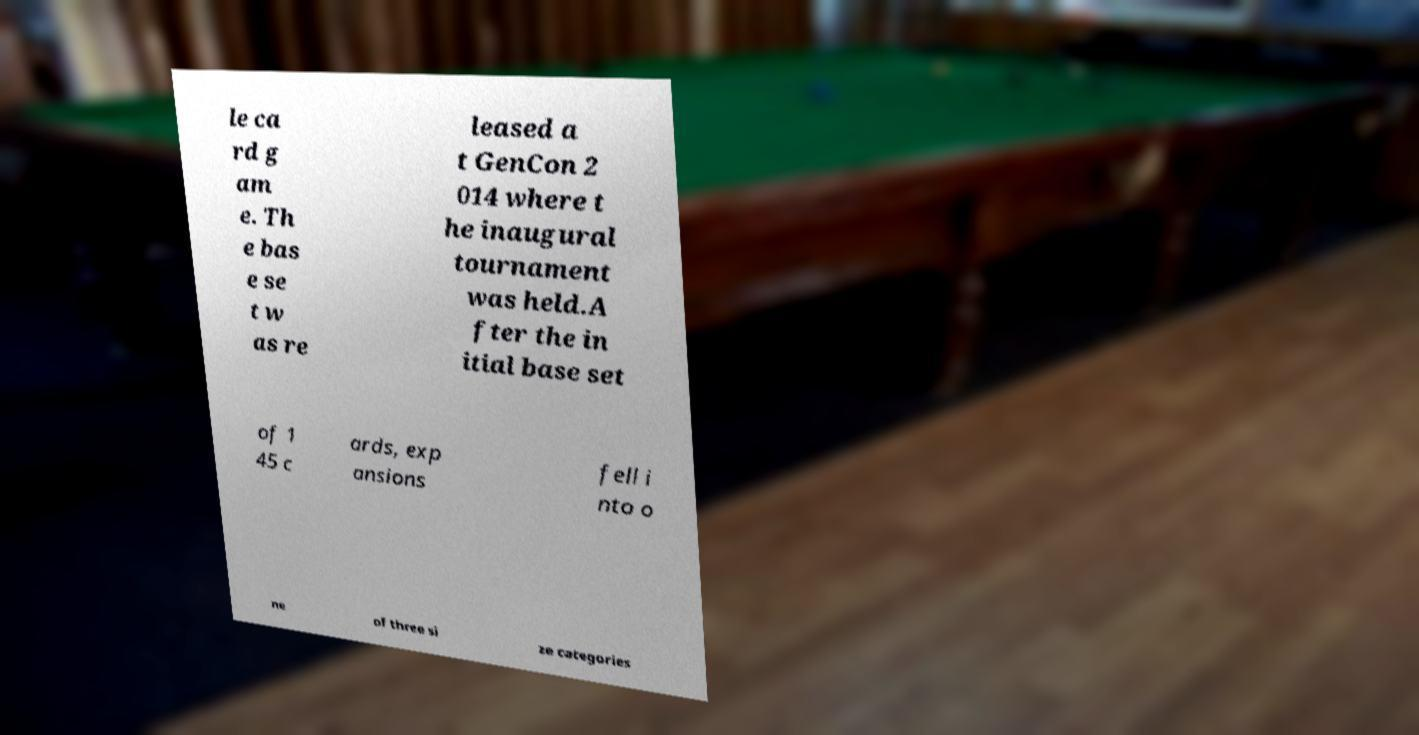There's text embedded in this image that I need extracted. Can you transcribe it verbatim? le ca rd g am e. Th e bas e se t w as re leased a t GenCon 2 014 where t he inaugural tournament was held.A fter the in itial base set of 1 45 c ards, exp ansions fell i nto o ne of three si ze categories 